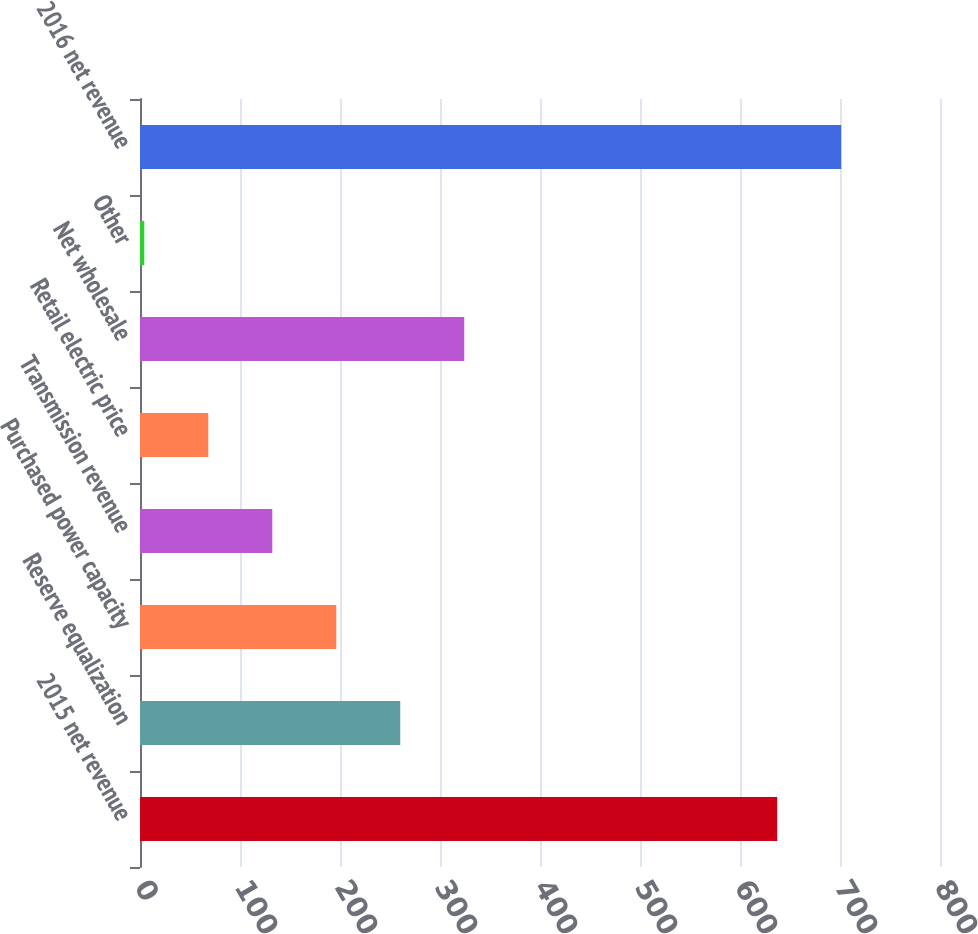Convert chart. <chart><loc_0><loc_0><loc_500><loc_500><bar_chart><fcel>2015 net revenue<fcel>Reserve equalization<fcel>Purchased power capacity<fcel>Transmission revenue<fcel>Retail electric price<fcel>Net wholesale<fcel>Other<fcel>2016 net revenue<nl><fcel>637.2<fcel>260.26<fcel>196.27<fcel>132.28<fcel>68.29<fcel>324.25<fcel>4.3<fcel>701.19<nl></chart> 